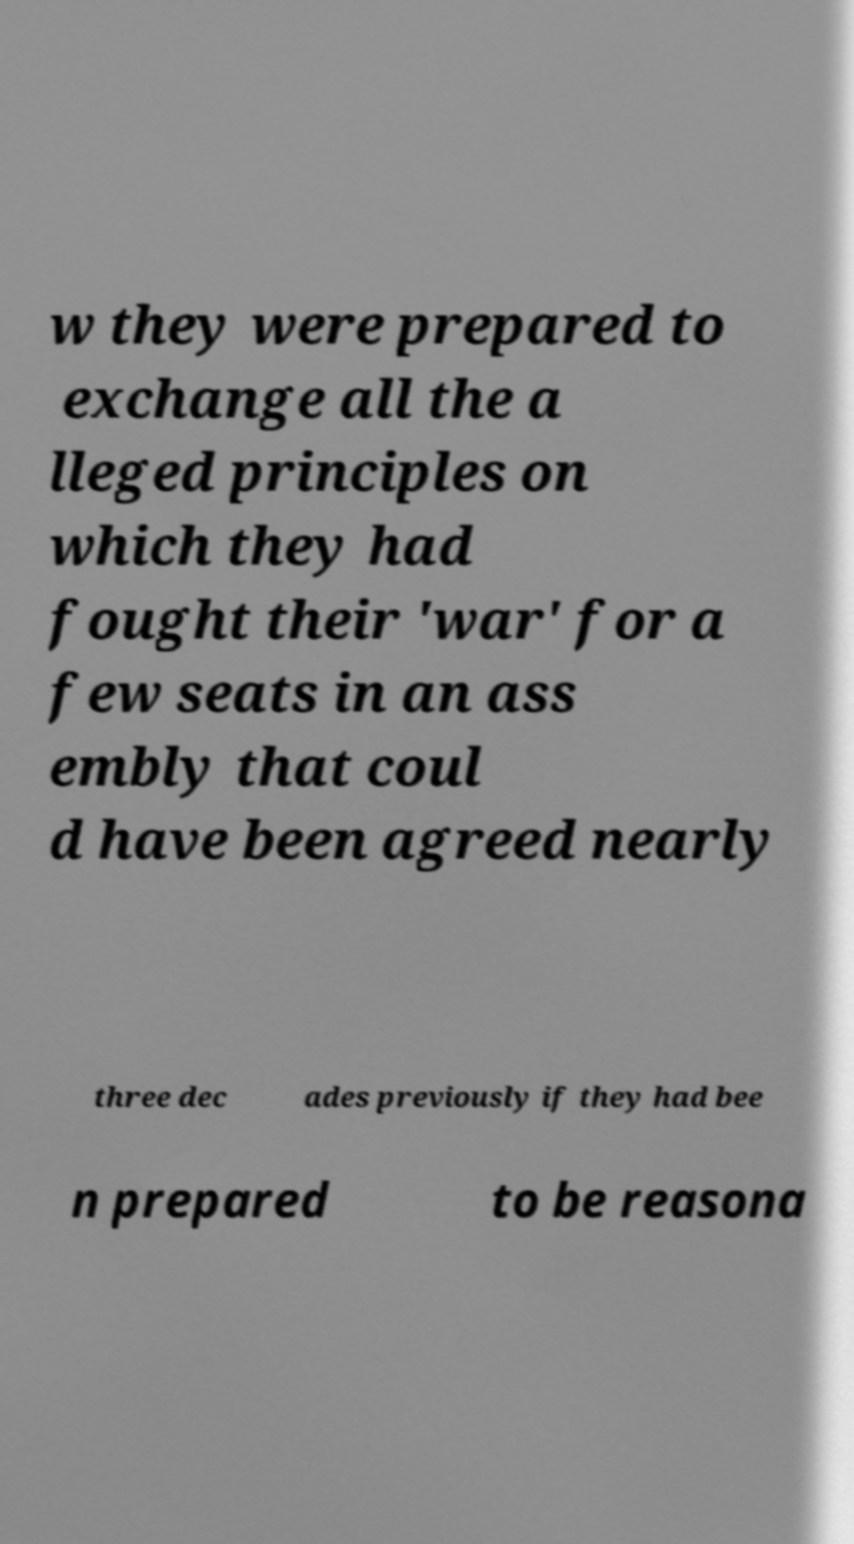There's text embedded in this image that I need extracted. Can you transcribe it verbatim? w they were prepared to exchange all the a lleged principles on which they had fought their 'war' for a few seats in an ass embly that coul d have been agreed nearly three dec ades previously if they had bee n prepared to be reasona 